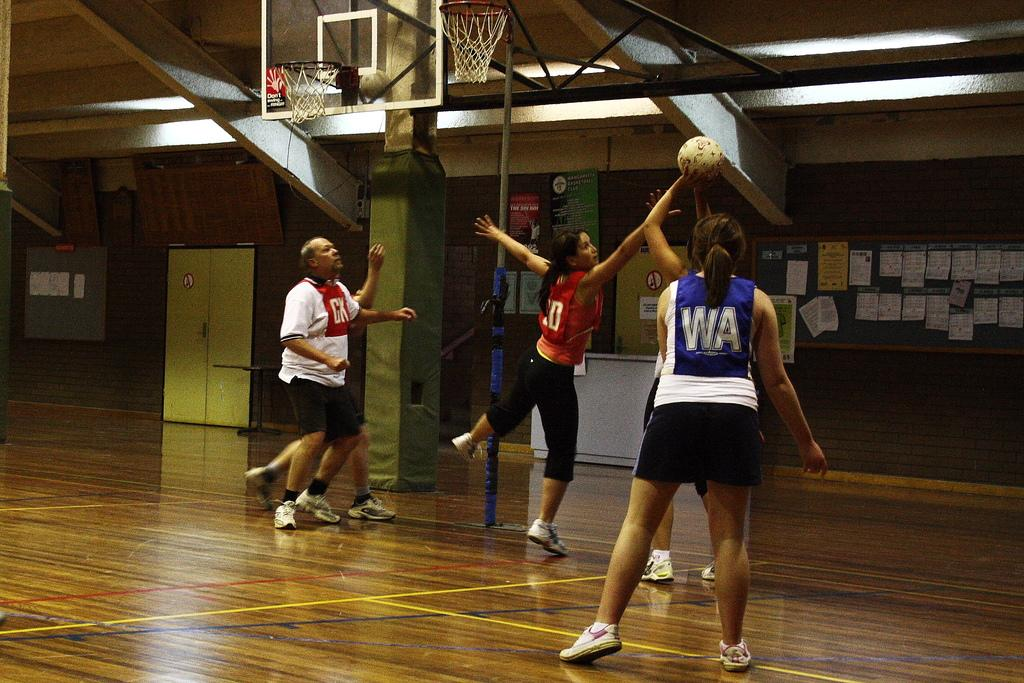Provide a one-sentence caption for the provided image. The player for CK tries to block the shot of of the player for WA. 